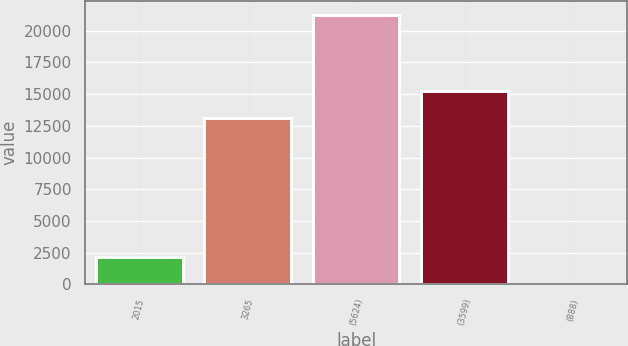<chart> <loc_0><loc_0><loc_500><loc_500><bar_chart><fcel>2015<fcel>3265<fcel>(5624)<fcel>(3599)<fcel>(888)<nl><fcel>2158.8<fcel>13145<fcel>21268<fcel>15268.2<fcel>35.55<nl></chart> 